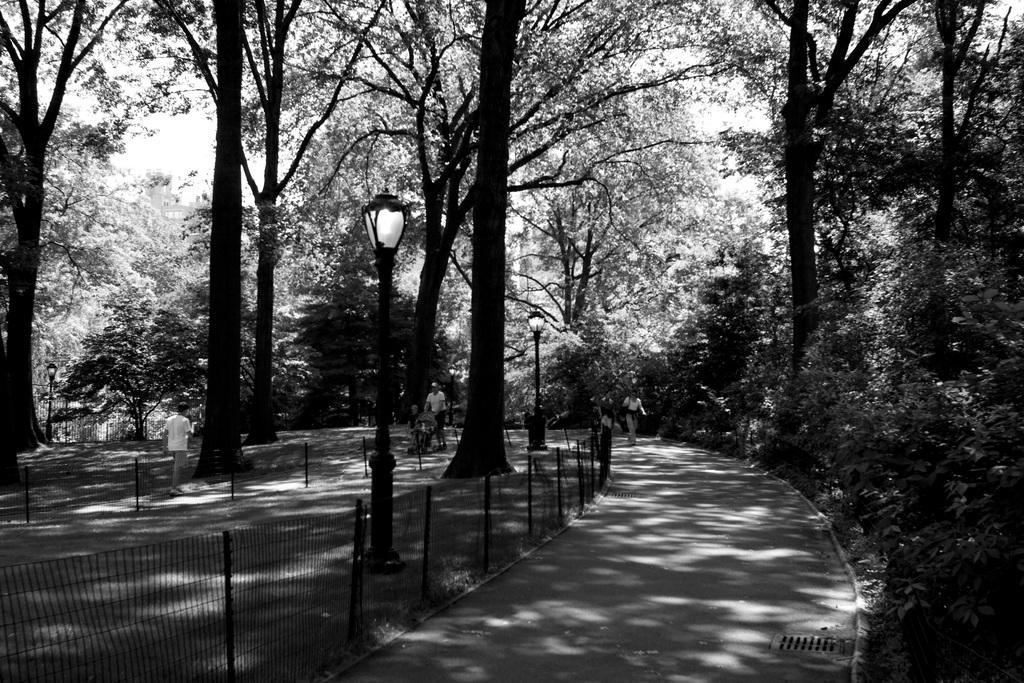How would you summarize this image in a sentence or two? This picture is in black and white. At the bottom right, there is a lane. On either side of the lane there are trees. In the center, there is a person holding a baby vehicle. In the center, there is a pole. 